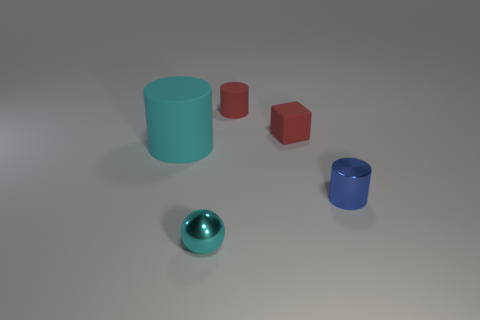Is there any other thing of the same color as the tiny metal cylinder?
Offer a terse response. No. There is a small cylinder that is in front of the cyan object that is behind the small metal object that is in front of the shiny cylinder; what is its color?
Make the answer very short. Blue. There is a metal thing that is left of the small cylinder in front of the red cube; what size is it?
Offer a terse response. Small. There is a small object that is both behind the tiny shiny cylinder and to the left of the red cube; what material is it made of?
Keep it short and to the point. Rubber. Does the blue thing have the same size as the cylinder that is behind the large cyan thing?
Your response must be concise. Yes. Are there any tiny purple rubber balls?
Your answer should be compact. No. There is a tiny blue object that is the same shape as the large cyan object; what is it made of?
Keep it short and to the point. Metal. What is the size of the cylinder that is left of the cyan object that is in front of the rubber object that is left of the cyan ball?
Provide a short and direct response. Large. There is a tiny matte cylinder; are there any tiny things in front of it?
Make the answer very short. Yes. What size is the sphere that is the same material as the blue cylinder?
Keep it short and to the point. Small. 